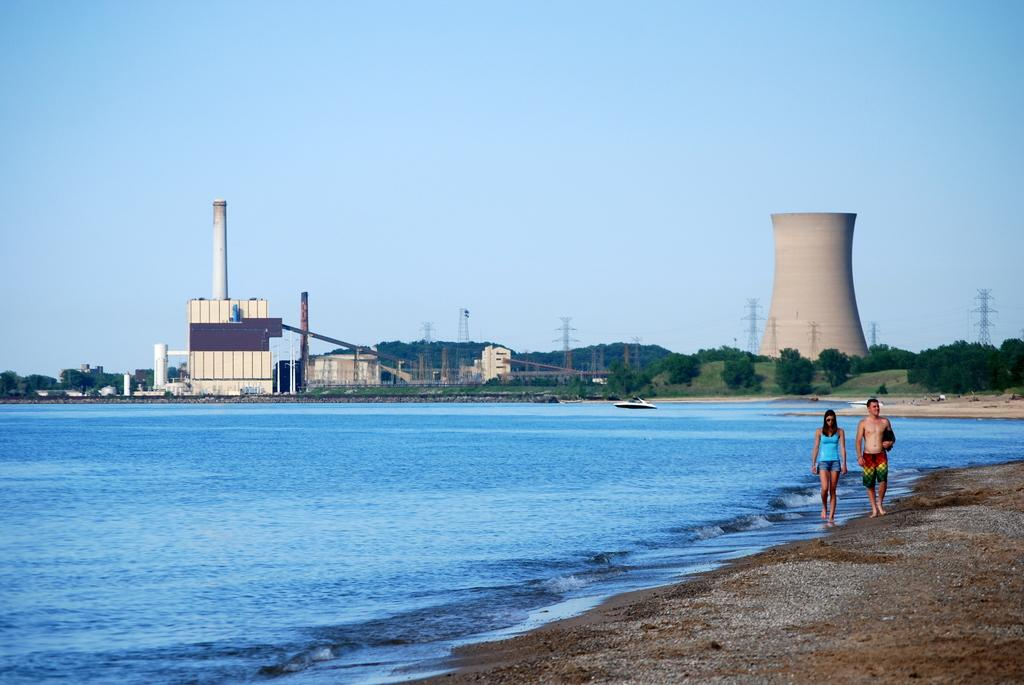Who can be seen in the image? There is a couple in the image. What are the couple doing in the image? The couple is walking down the river. What structures are present in the image? There is a power plant and cooling towers in the image. What type of vegetation is visible in the image? Trees are visible in the image. What can be seen in the background of the image? The sky is visible in the background of the image. What type of balls can be seen bouncing around in the image? There are no balls present in the image. What is the temperature of the town in the image? There is no town present in the image, so it is not possible to determine the temperature. 